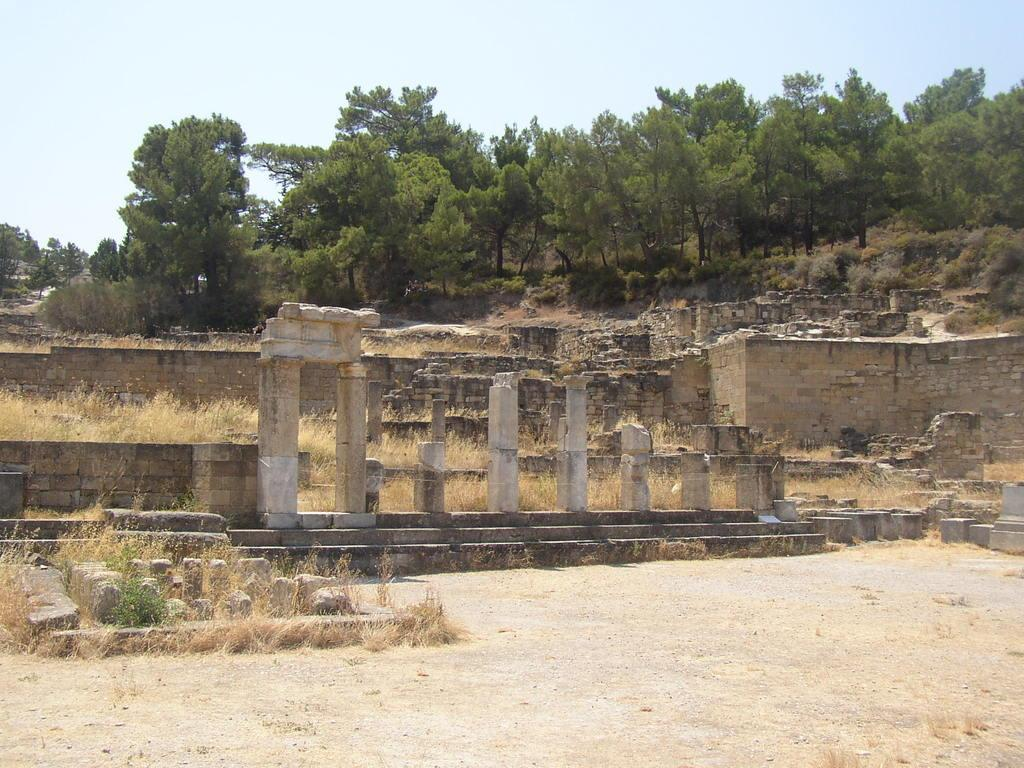What type of structure can be seen in the image? There is a wall in the image. Are there any architectural features present? Yes, there are pillars in the image. What is the condition of the vegetation in the image? Dry grass is visible in the image. What part of the natural environment is visible in the image? The ground is visible in the image. What can be seen in the background of the image? Trees and the clear sky are visible in the background of the image. How many seeds are visible in the image? There are no seeds present in the image. What type of mask is being worn by the passenger in the image? There is no passenger or mask present in the image. 